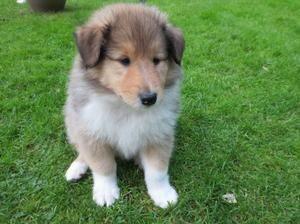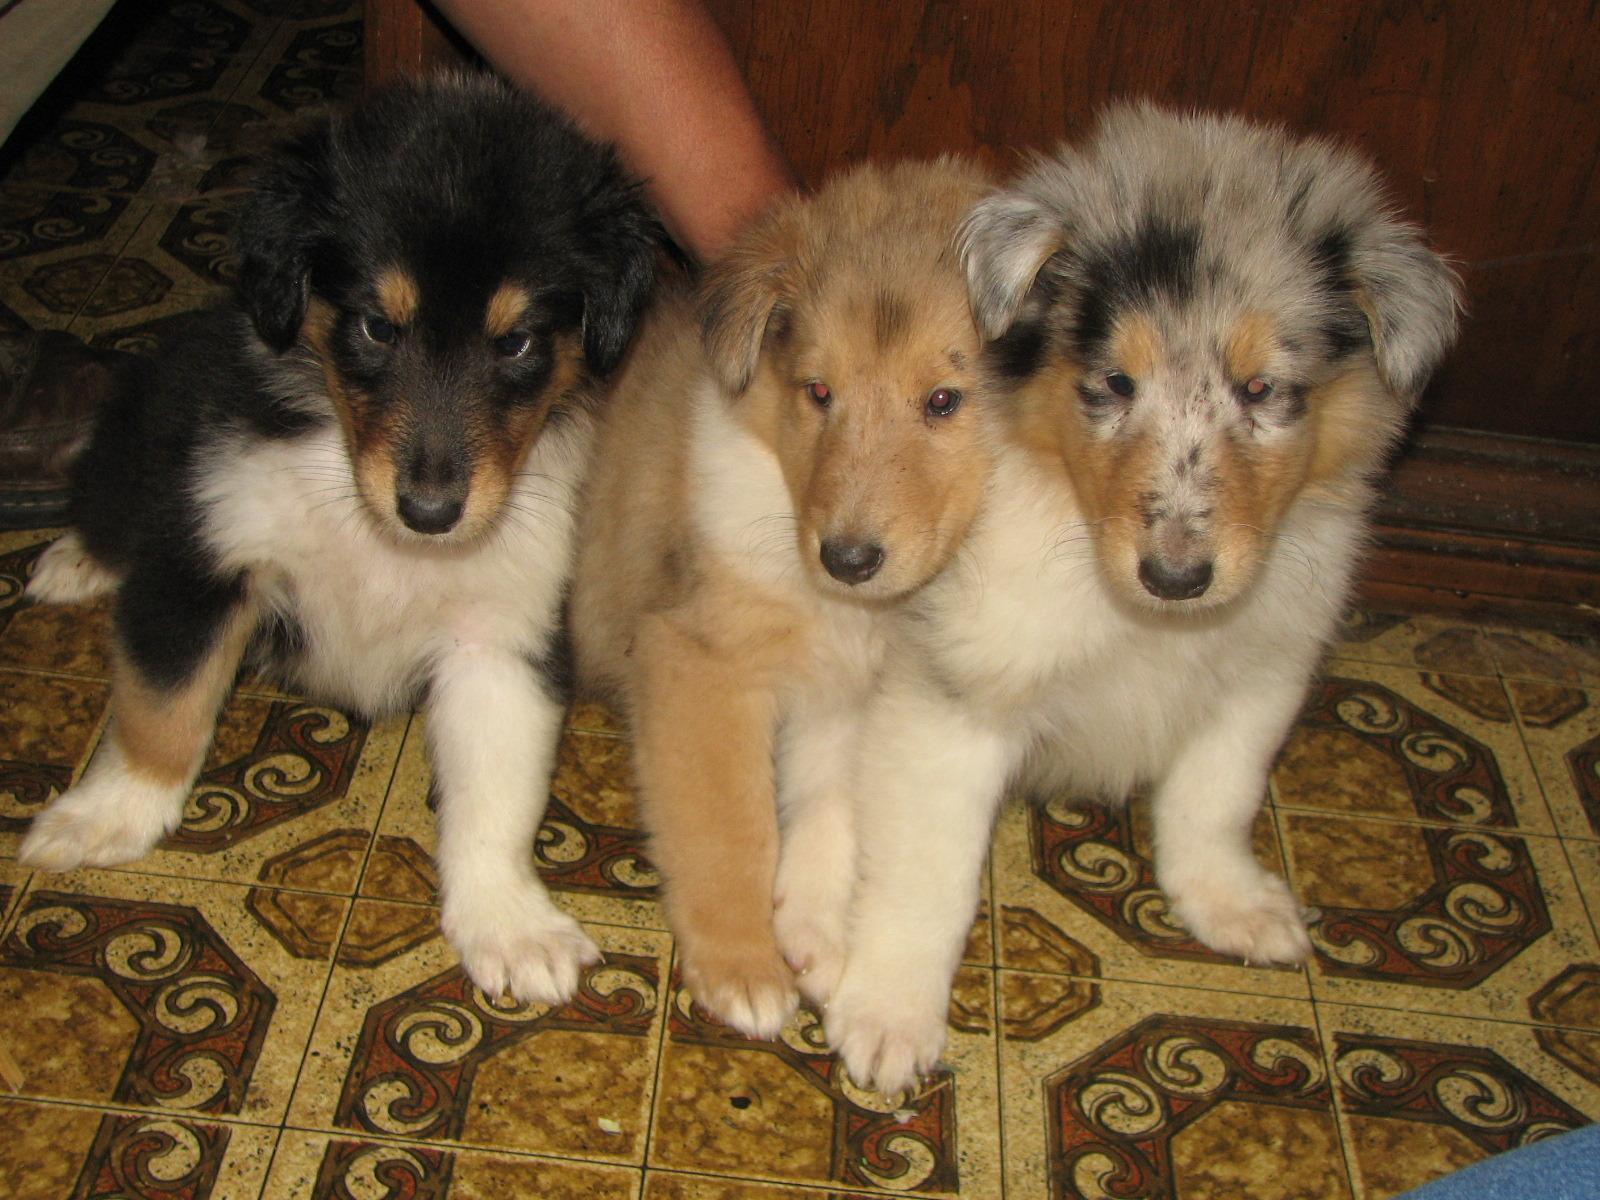The first image is the image on the left, the second image is the image on the right. For the images displayed, is the sentence "The right image contains exactly two dogs." factually correct? Answer yes or no. No. The first image is the image on the left, the second image is the image on the right. Analyze the images presented: Is the assertion "A reclining adult collie is posed alongside a collie pup sitting upright." valid? Answer yes or no. No. 